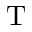<formula> <loc_0><loc_0><loc_500><loc_500>T</formula> 